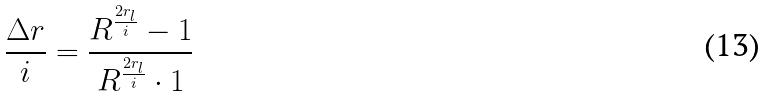<formula> <loc_0><loc_0><loc_500><loc_500>\frac { \Delta r } { i } = \frac { R ^ { \frac { 2 r _ { l } } { i } } - 1 } { R ^ { \frac { 2 r _ { l } } { i } } \cdot 1 }</formula> 